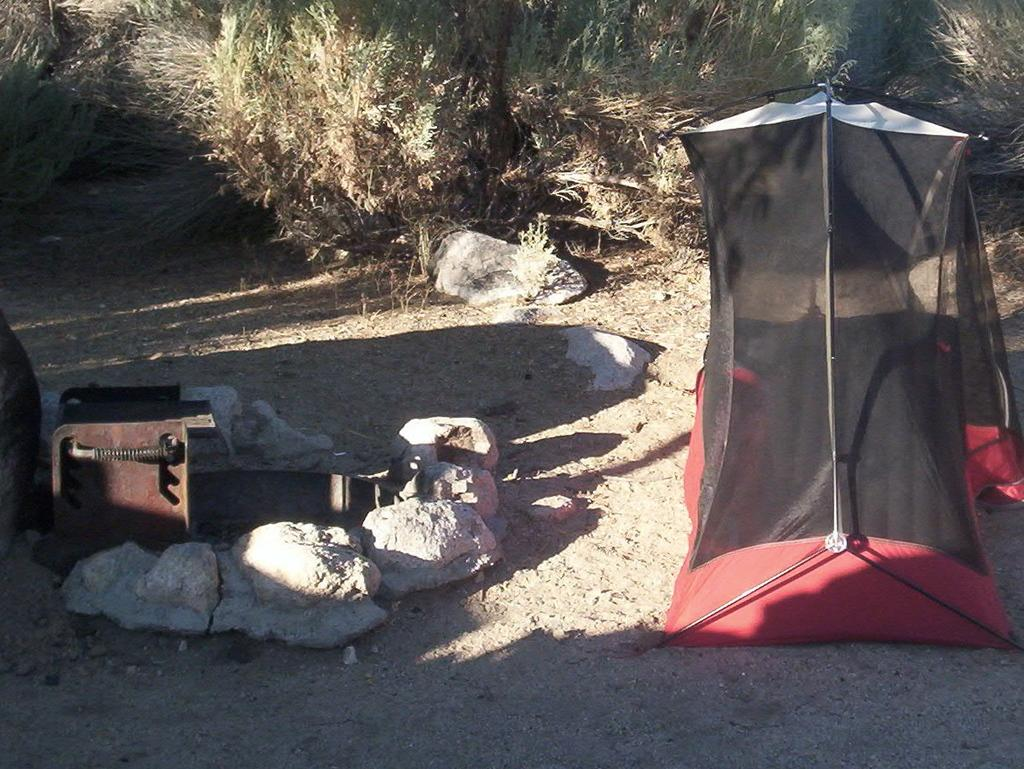What type of shelter is visible in the image? There is a tent in the image. What natural elements can be seen in the image? Stones, shredded leaves, shrubs, and lawn straw are present in the image. Can you describe the vegetation in the image? Shrubs are visible in the image. How does the sink function in the image? There is no sink present in the image. What type of hot beverage can be seen in the image? There is no hot beverage present in the image. 